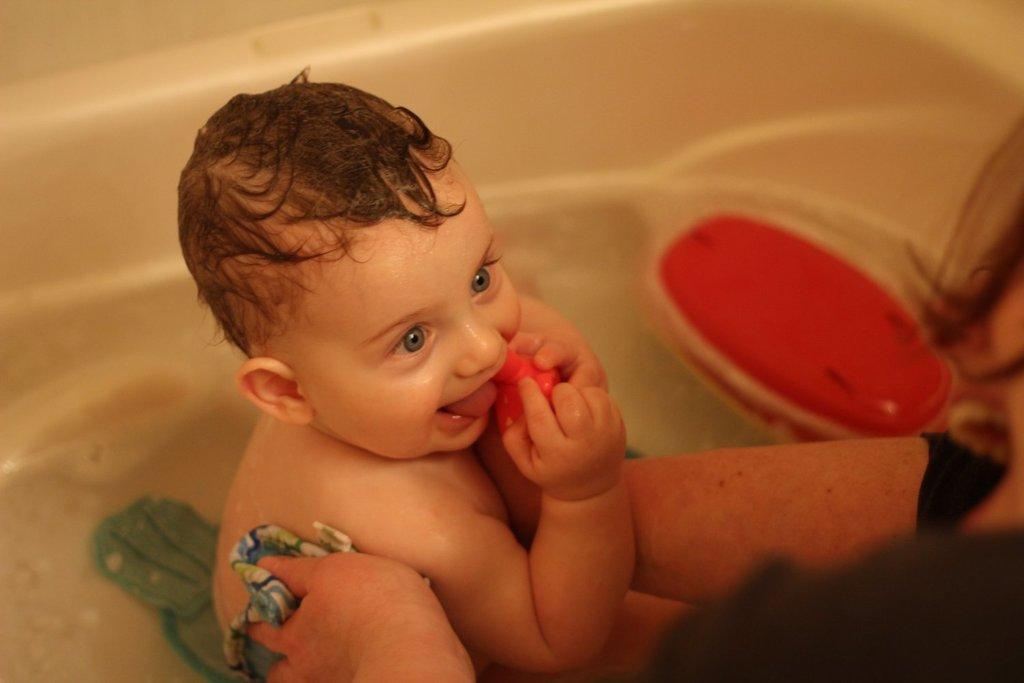How would you summarize this image in a sentence or two? In this image we can see a baby in the bathtub. There is a woman to the right side of the image. 